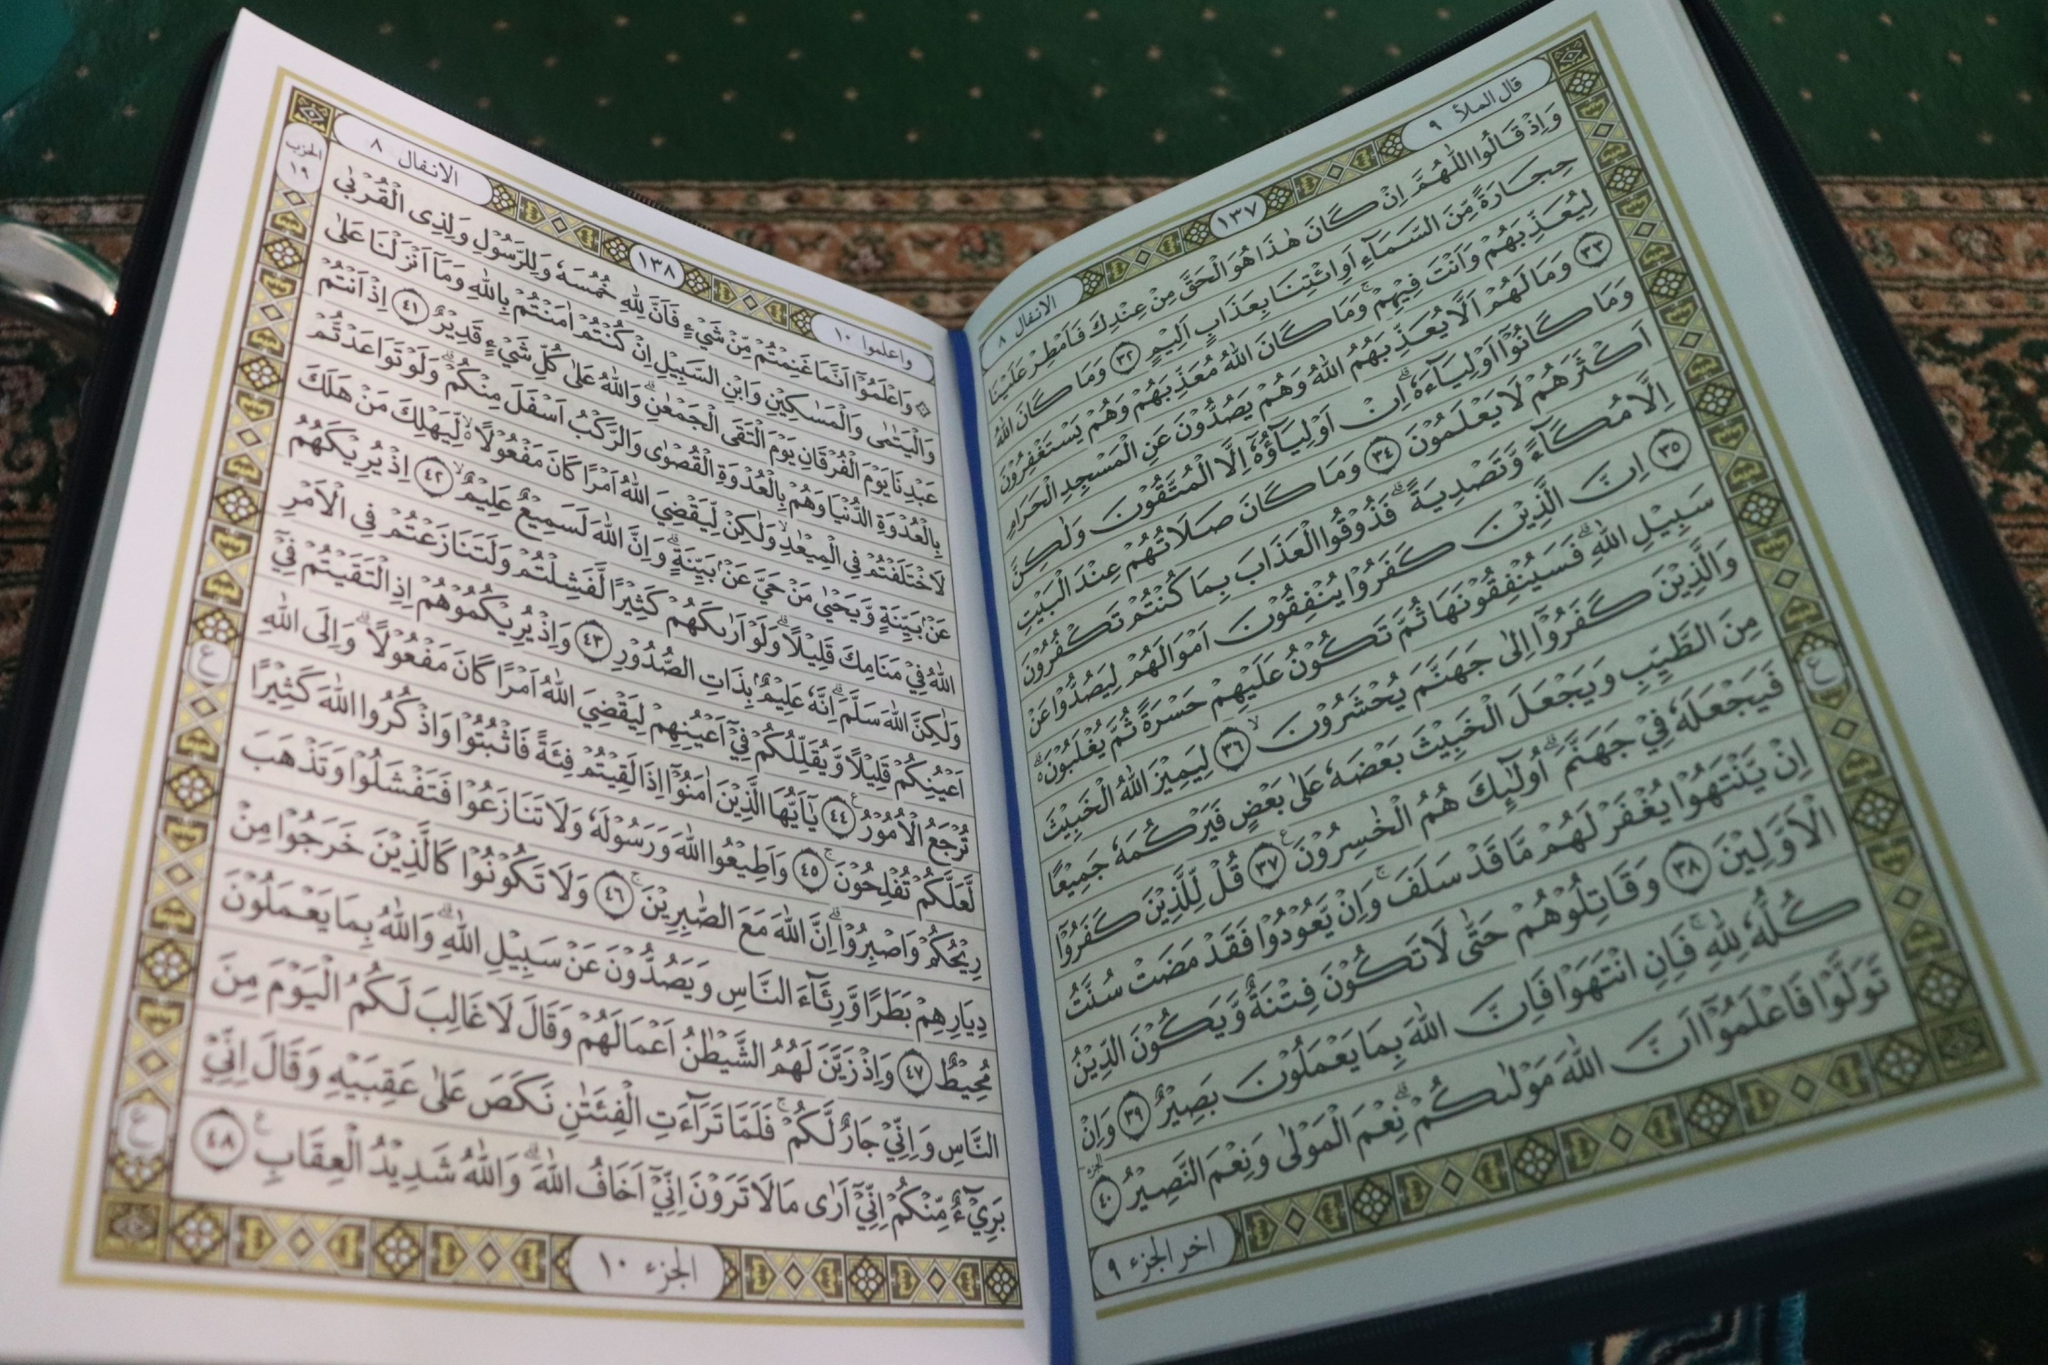Based on this image, imagine you are an archaeologist who just discovered this book. Describe your next steps. As an archaeologist who has just unearthed this remarkable book, my immediate next steps would be to ensure its preservation and protection. Given the book's potential historical and cultural significance, I would carefully document its condition through detailed notes and high-resolution photographs. Working with conservators, our priority would be to stabilize the book to prevent further degradation, using non-invasive techniques and preservation environments. I would then catalog it in our database, noting its physical characteristics, language, and any distinctive markings. To better understand its origins and significance, I would collaborate with linguists, historians, and religious scholars, conducting a thorough analysis of its content. Our goal would be to uncover the context of the book, its place within history, and its impact on the culture from which it originated. Eventually, I would prepare to share our findings through academic publications and museum exhibitions, bringing this extraordinary discovery to the attention of the scholarly community and the public.  What's a short, realistic scenario involving a person interacting with this book? A devoted reader sits quietly in a serene corner of a room, the sacred book open before them. They gently turn the delicate pages, their fingers tracing the elegant Arabic calligraphy. As they read the verses, their eyes reflect a sense of peace and introspection. Lost in thought, they pause occasionally to meditate on the teachings, finding comfort and guidance in the ancient wisdom embedded in the text.  What's a long, realistic scenario involving a person interacting with this book? In a dimly lit room filled with the gentle flicker of candlelight, an elderly scholar sits at an ornate wooden desk. The sacred book is open in front of them, its pages worn but well-cared-for, bearing the weight of years of reverent study. The scholar adjusts their glasses and begins their nightly ritual of reading, studying the intricate calligraphy and pondering the profound messages within the verses. As they read, they occasionally make annotations in a leather-bound journal, carefully interpreting the meanings and reflecting on the historical context. During moments of deep contemplation, the scholar looks up, their gaze distant as they connect the ancient wisdom to contemporary issues and personal experiences. This serene practice not only nurtures their spiritual growth but also enhances their ongoing scholarly work, contributing valuable insights to the academic and religious communities. The quietude of the room, punctuated only by the sound of a page turning or the soft murmur of the scholar’s voice as they recite a verse, creates an atmosphere of deep reverence and intellectual pursuit. 